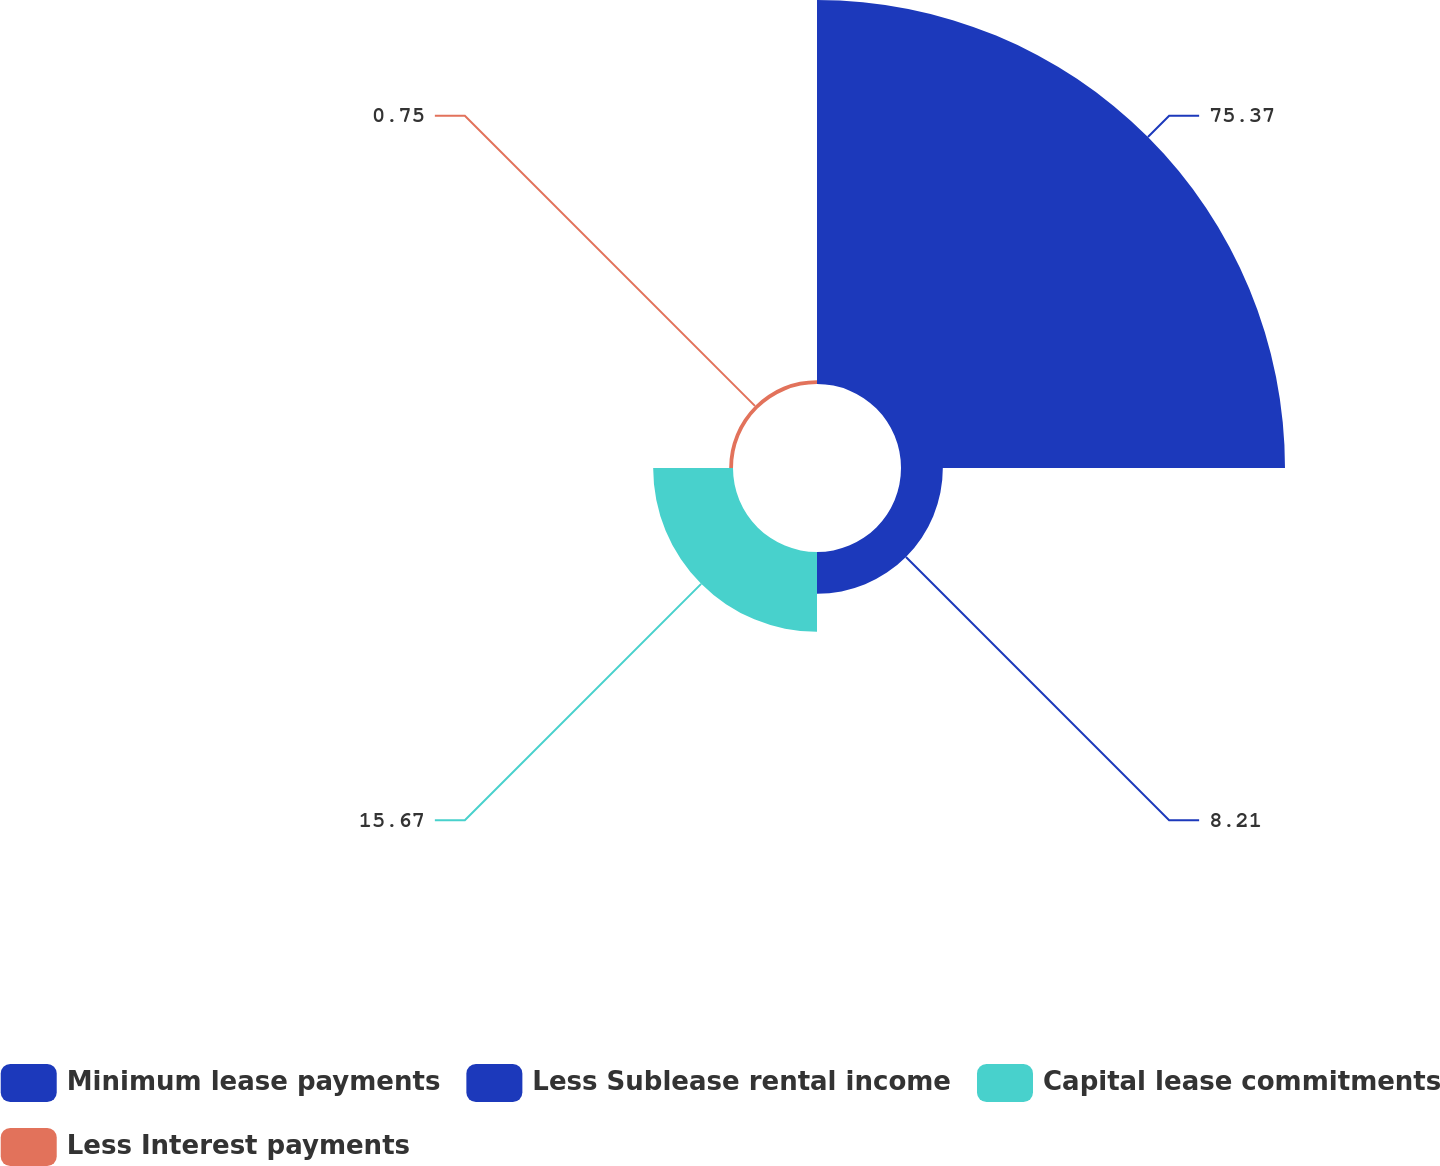Convert chart. <chart><loc_0><loc_0><loc_500><loc_500><pie_chart><fcel>Minimum lease payments<fcel>Less Sublease rental income<fcel>Capital lease commitments<fcel>Less Interest payments<nl><fcel>75.37%<fcel>8.21%<fcel>15.67%<fcel>0.75%<nl></chart> 